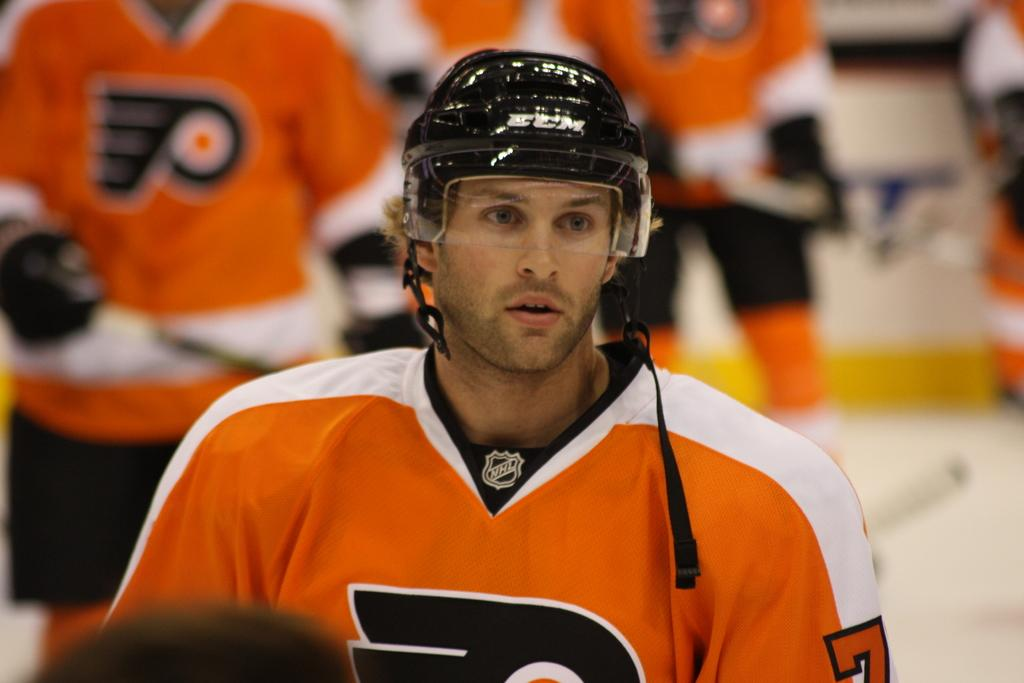What is the man in the image wearing on his head? The man in the image is wearing a helmet. Can you describe the people in the background of the image? The image is blurry, so it is difficult to provide a detailed description of the people in the background. What type of bait is the man using in the image? There is no bait present in the image; the man is wearing a helmet. What committee is responsible for the decisions made in the image? There is no committee mentioned or depicted in the image. 